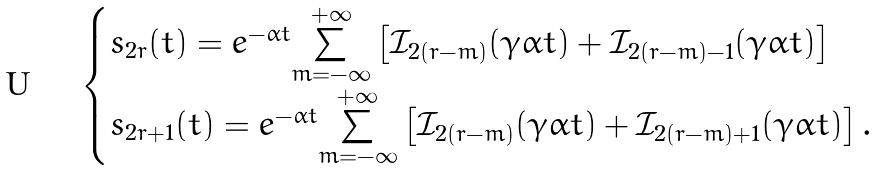<formula> <loc_0><loc_0><loc_500><loc_500>\begin{cases} s _ { 2 r } ( t ) = e ^ { - \alpha t } \overset { + \infty } { \underset { m = - \infty } \sum } \left [ \mathcal { I } _ { 2 ( r - m ) } ( \gamma \alpha t ) + \mathcal { I } _ { 2 ( r - m ) - 1 } ( \gamma \alpha t ) \right ] \\ s _ { 2 r + 1 } ( t ) = e ^ { - \alpha t } \overset { + \infty } { \underset { m = - \infty } \sum } \left [ \mathcal { I } _ { 2 ( r - m ) } ( \gamma \alpha t ) + \mathcal { I } _ { 2 ( r - m ) + 1 } ( \gamma \alpha t ) \right ] . \end{cases}</formula> 